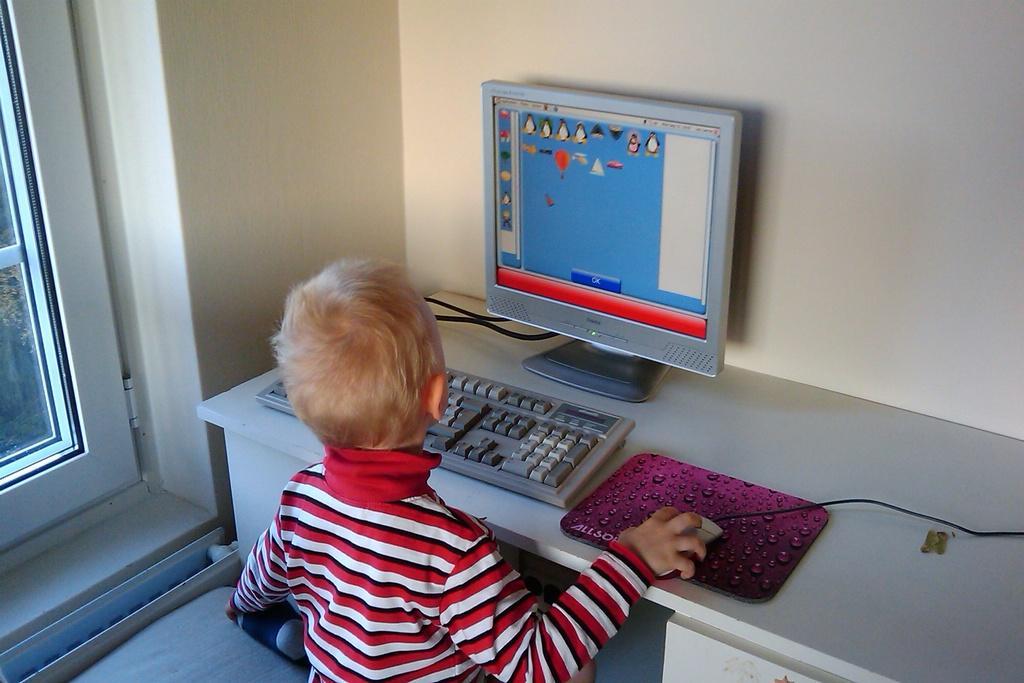In one or two sentences, can you explain what this image depicts? here we can see a small boy operating a system which is in front of him on a table. 